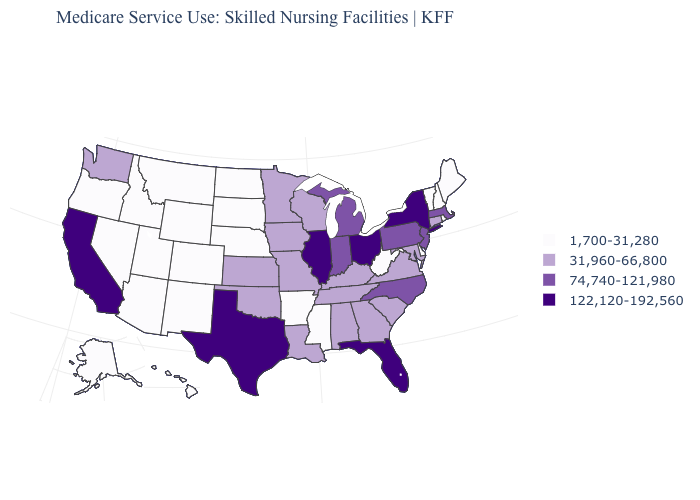What is the highest value in the USA?
Concise answer only. 122,120-192,560. What is the lowest value in the West?
Be succinct. 1,700-31,280. What is the value of California?
Write a very short answer. 122,120-192,560. Does Nevada have the same value as Arizona?
Answer briefly. Yes. Does California have the lowest value in the West?
Short answer required. No. What is the value of Louisiana?
Concise answer only. 31,960-66,800. Which states have the lowest value in the USA?
Short answer required. Alaska, Arizona, Arkansas, Colorado, Delaware, Hawaii, Idaho, Maine, Mississippi, Montana, Nebraska, Nevada, New Hampshire, New Mexico, North Dakota, Oregon, Rhode Island, South Dakota, Utah, Vermont, West Virginia, Wyoming. Does the first symbol in the legend represent the smallest category?
Be succinct. Yes. What is the value of North Carolina?
Write a very short answer. 74,740-121,980. Is the legend a continuous bar?
Be succinct. No. Among the states that border Utah , which have the lowest value?
Be succinct. Arizona, Colorado, Idaho, Nevada, New Mexico, Wyoming. What is the lowest value in the USA?
Quick response, please. 1,700-31,280. What is the highest value in the MidWest ?
Keep it brief. 122,120-192,560. Does the first symbol in the legend represent the smallest category?
Quick response, please. Yes. What is the value of Oregon?
Give a very brief answer. 1,700-31,280. 